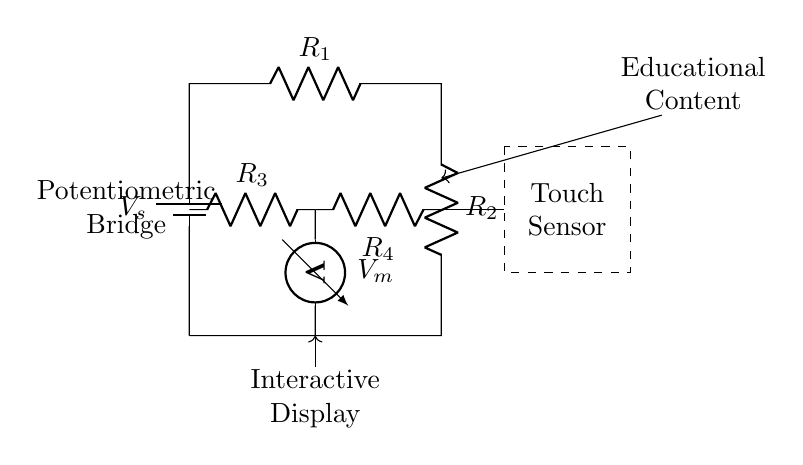What is the voltage source in this circuit? The voltage source is labeled as V_s, which indicates the supply voltage for the potentiometric bridge circuit.
Answer: V_s What are the resistors labeled in this circuit? The resistors are labeled R_1, R_2, R_3, and R_4, indicating four distinct resistance components within the circuit.
Answer: R_1, R_2, R_3, R_4 What is the function of the voltmeter in this circuit? The voltmeter, labeled as V_m, measures the voltage across a specific section of the circuit, indicating the electrical potential difference.
Answer: Measure voltage Which component connects to the touch sensor? The connection to the touch sensor is made from the node between R_3 and R_4, depicting its integration into the circuit's voltage measurement system.
Answer: R_4 Explain the relationship between the resistors R_3 and R_4. R_3 and R_4 are arranged in parallel across the middle of the bridge circuit, affecting the overall voltage experienced at V_m and indicating how the resistances interact to alter voltage measurement based on touch input.
Answer: Parallel configuration What role does the interactive display play in this circuit? The interactive display is coupled with the output from the circuit, receiving signals for the educational content based on voltage variations detected through the bridge circuit, enabling user engagement.
Answer: Display content How does the potentiometric bridge circuit create touch sensitivity? The touch sensitivity arises from the changes in resistance and resulting voltage at V_m when the touch sensor detects contact, allowing for variations in output that correspond to user interactions with the display.
Answer: By changing resistance 